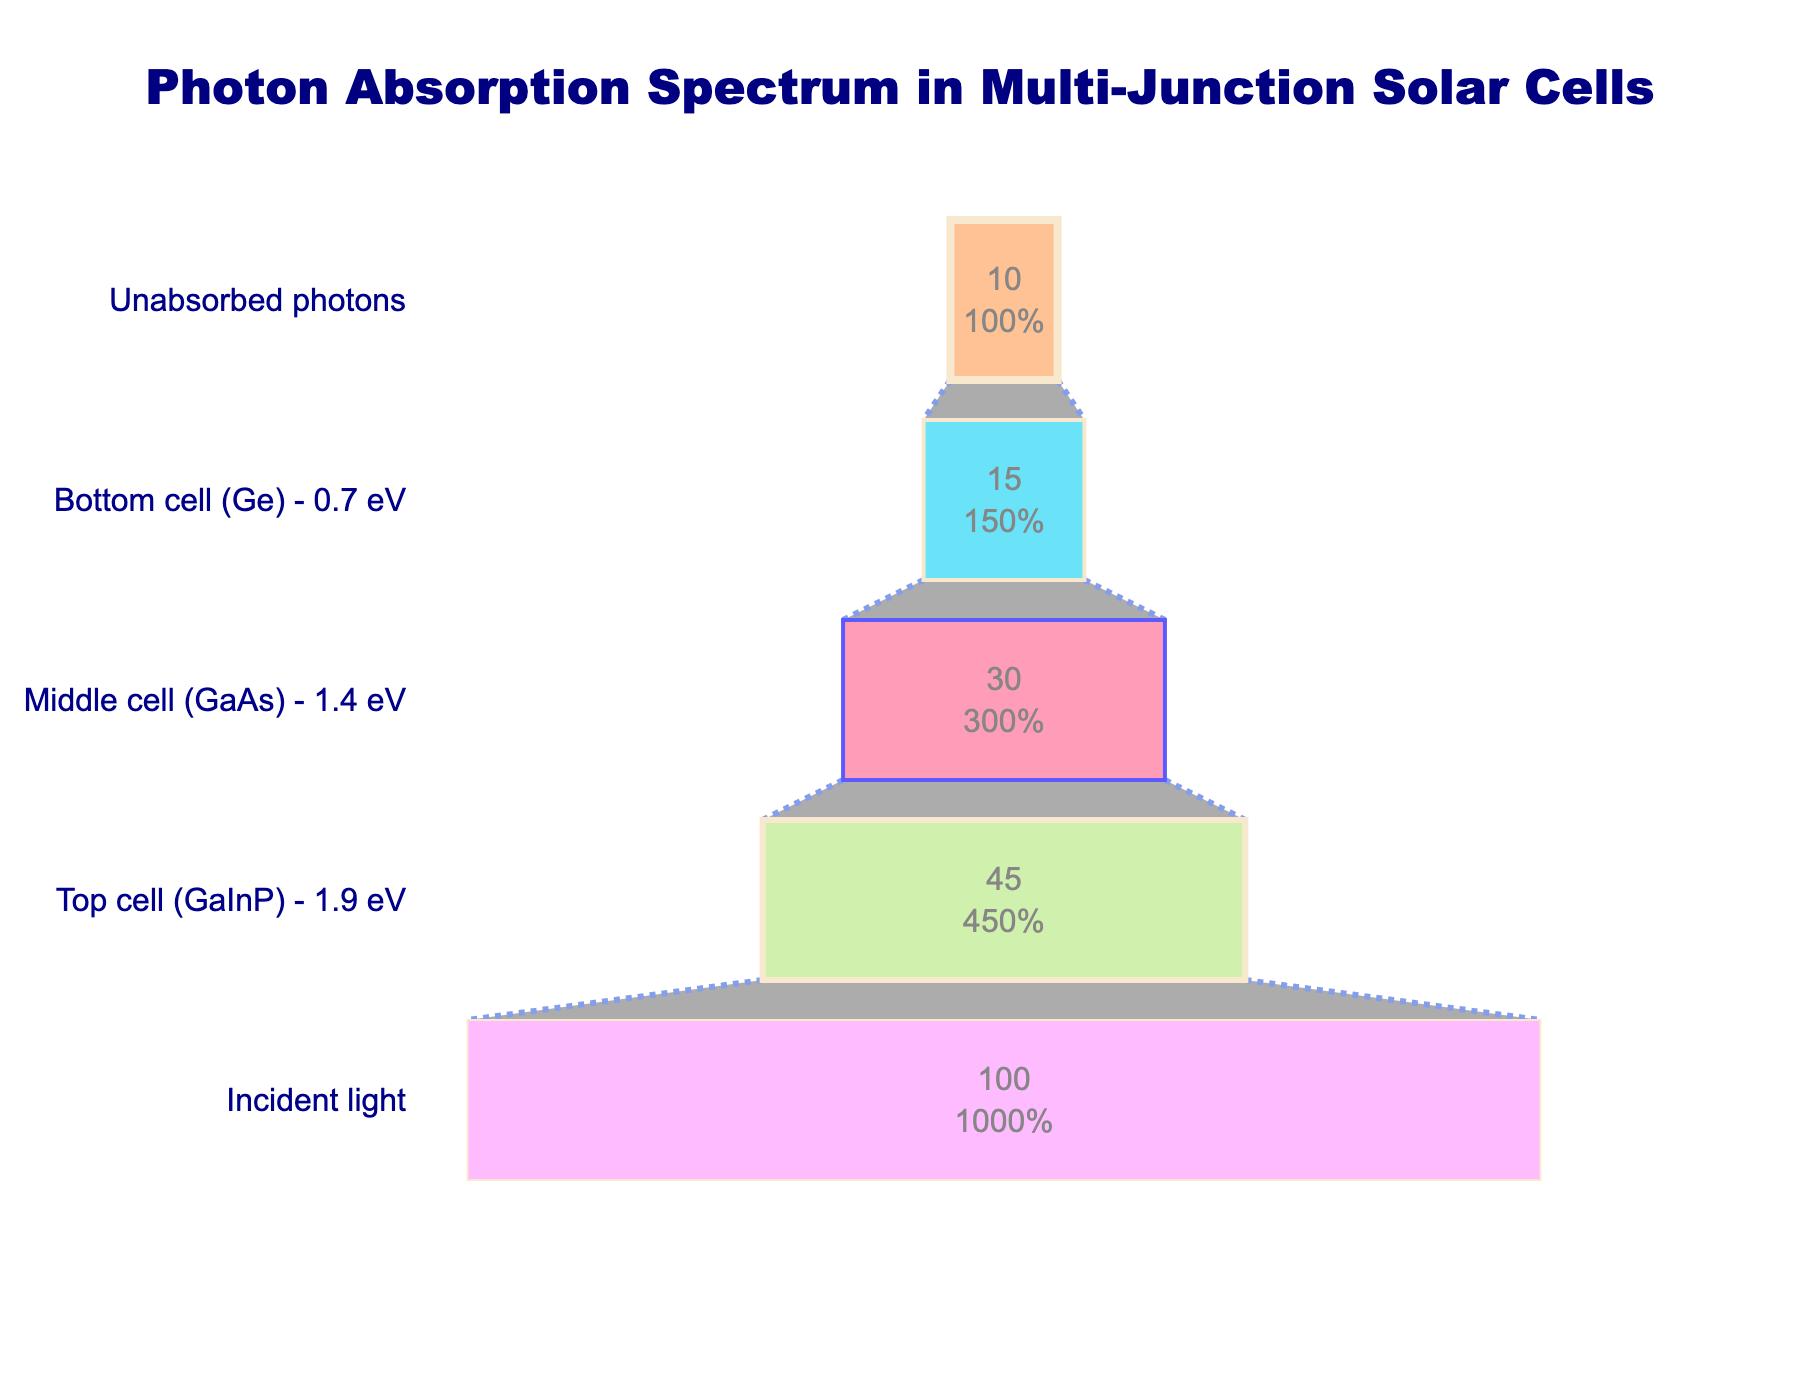What is the title of the chart? The title of the chart is typically the largest text at the top of the figure, providing an overview of the chart’s content. Here, it reads "Photon Absorption Spectrum in Multi-Junction Solar Cells," indicating the subject of the analysis.
Answer: Photon Absorption Spectrum in Multi-Junction Solar Cells Which cell absorbs the most photons? Observing the funnel chart, each stage represents a different cell and their respective photon absorption percentages. The largest decrement from the preceding stage indicates the highest absorption. In this chart, the top cell (GaInP) shows the highest absorption.
Answer: Top cell (GaInP) How many photons are absorbed by the middle and bottom cells combined? To find the combined absorption of the middle and bottom cells, sum the values for both cells. The middle cell absorbs 30%, and the bottom cell absorbs 15%, leading to a combined total of 30% + 15% = 45%.
Answer: 45% What percentage of photons remain unabsorbed after passing through all the cells? The funnel chart shows different stages and the ending stage provides the percentage of unabsorbed photons. Here, the last stage indicates 10% unabsorbed photons.
Answer: 10% Which cell absorbs more photons, the middle cell or the bottom cell? Compare the photon absorption percentages of the middle and bottom cells. The middle cell's absorption is 30%, while the bottom cell's absorption is 15%. The middle cell absorbs more photons.
Answer: Middle cell How much more efficient is the top cell compared to the bottom cell in terms of photon absorption? To determine how much more efficient the top cell is, subtract the percentage absorbed by the bottom cell from that of the top cell. Efficiency difference = 45% - 15% = 30%.
Answer: 30% What is the total percentage of photons absorbed by all three cells combined? Sum the percentages absorbed by the top cell, middle cell, and bottom cell. This is calculated as 45% (top) + 30% (middle) + 15% (bottom) = 90%.
Answer: 90% What stage in the funnel chart marks the transition to unabsorbed photons? The stage before the final stage represents the total photons that are not absorbed by the cells. In this chart, the "Bottom cell (Ge) - 0.7 eV" stage marks this transition before the "Unabsorbed photons" stage.
Answer: Bottom cell (Ge) - 0.7 eV 